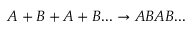<formula> <loc_0><loc_0><loc_500><loc_500>A + B + A + B \dots \rightarrow A B A B \dots</formula> 